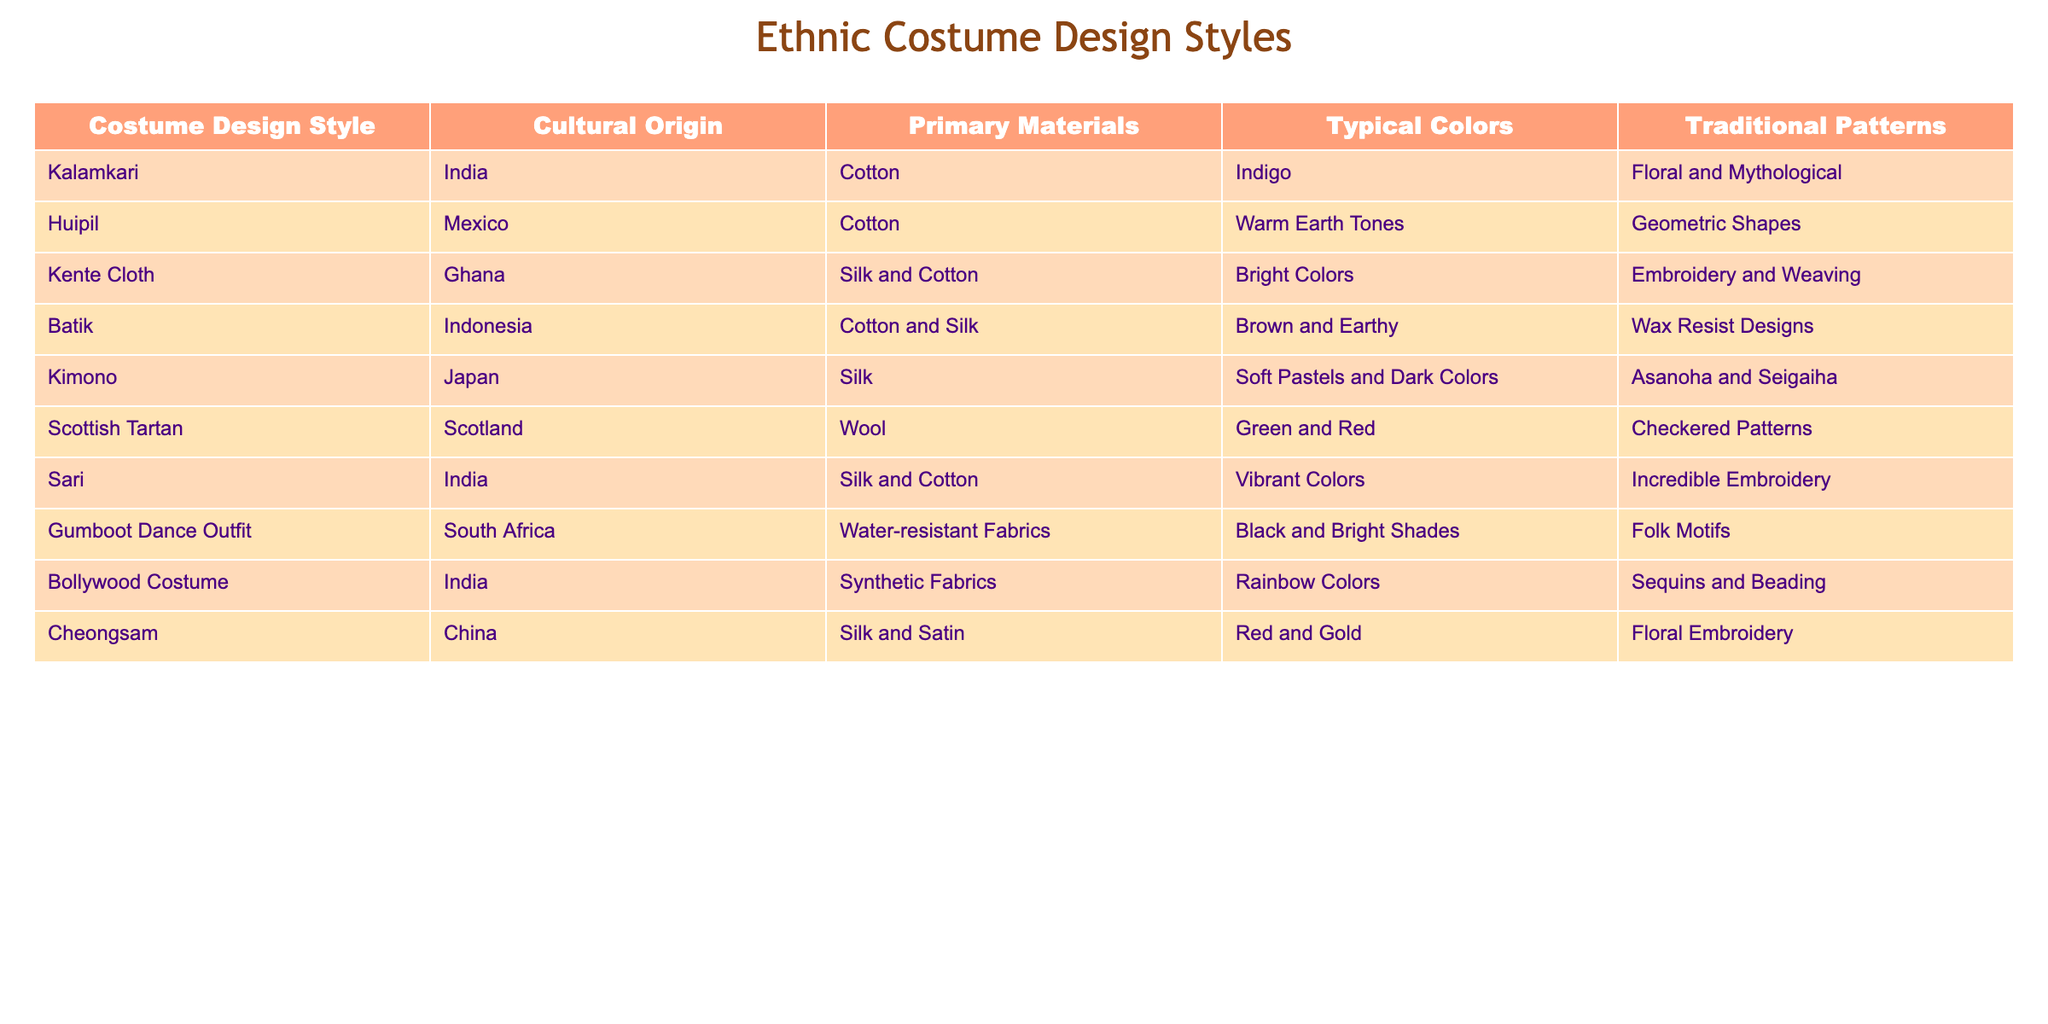What is the primary material used in Kente Cloth? The table lists "Kente Cloth" under the "Costume Design Style" column. Looking at the same row in the "Primary Materials" column, it shows that Kente Cloth is made of "Silk and Cotton".
Answer: Silk and Cotton Which costume design style uses water-resistant fabrics? In the table, under the "Costume Design Style" column, the "Gumboot Dance Outfit" is listed. The corresponding "Primary Materials" column specifies "Water-resistant Fabrics".
Answer: Gumboot Dance Outfit Is the typical color of the Cheongsam red? The "Cheongsam" entry shows in the "Typical Colors" column that it uses "Red and Gold". Thus, it is true that the typical color includes red.
Answer: Yes How many costume design styles originate from India? The table includes three entries under the "Cultural Origin" column for India, specifically: "Kalamkari", "Sari", and "Bollywood Costume". This indicates that there are three costume design styles from India.
Answer: 3 Which design style features earthy colors and geometric shapes? Referring to the table, the "Huipil" style is associated with "Warm Earth Tones" and is listed under the "Traditional Patterns" column as "Geometric Shapes".
Answer: Huipil What is the dominant material in the Kimono? The "Kimono" entry has "Silk" listed in the "Primary Materials" column, indicating that silk is the dominant material used in this design.
Answer: Silk Are there any costume design styles that use synthetic fabrics? Looking at the "Bollywood Costume" under the "Primary Materials" column, it states "Synthetic Fabrics". Therefore, this statement is true.
Answer: Yes Which ethnic costume design style has the most vibrant colors? In the "Typical Colors" column for "Sari", it is stated that it has "Vibrant Colors", which shows it as the most vibrant compared to others listed in the table.
Answer: Sari What are the typical colors of the Scottish Tartan? The entry for "Scottish Tartan" in the "Typical Colors" column specifies "Green and Red", indicating these are the typical colors associated with this style.
Answer: Green and Red 